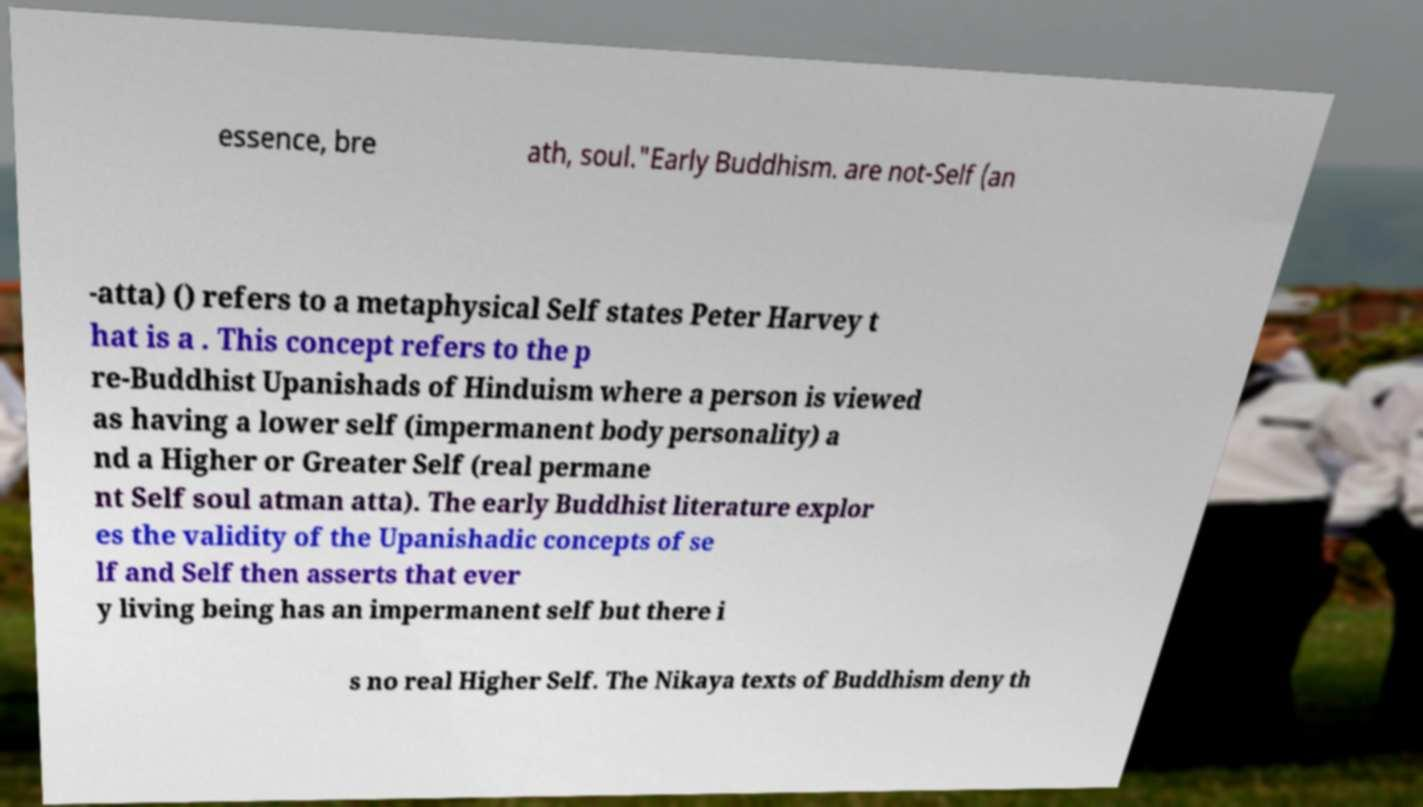Could you extract and type out the text from this image? essence, bre ath, soul."Early Buddhism. are not-Self (an -atta) () refers to a metaphysical Self states Peter Harvey t hat is a . This concept refers to the p re-Buddhist Upanishads of Hinduism where a person is viewed as having a lower self (impermanent body personality) a nd a Higher or Greater Self (real permane nt Self soul atman atta). The early Buddhist literature explor es the validity of the Upanishadic concepts of se lf and Self then asserts that ever y living being has an impermanent self but there i s no real Higher Self. The Nikaya texts of Buddhism deny th 